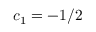Convert formula to latex. <formula><loc_0><loc_0><loc_500><loc_500>c _ { 1 } = - 1 / 2</formula> 